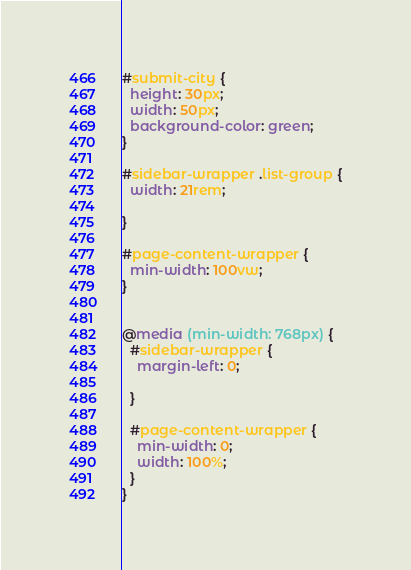<code> <loc_0><loc_0><loc_500><loc_500><_CSS_>
#submit-city {
  height: 30px;
  width: 50px;
  background-color: green;
}

#sidebar-wrapper .list-group {
  width: 21rem;

}

#page-content-wrapper {
  min-width: 100vw;
}


@media (min-width: 768px) {
  #sidebar-wrapper {
    margin-left: 0;
    
  }

  #page-content-wrapper {
    min-width: 0;
    width: 100%;
  }
}</code> 